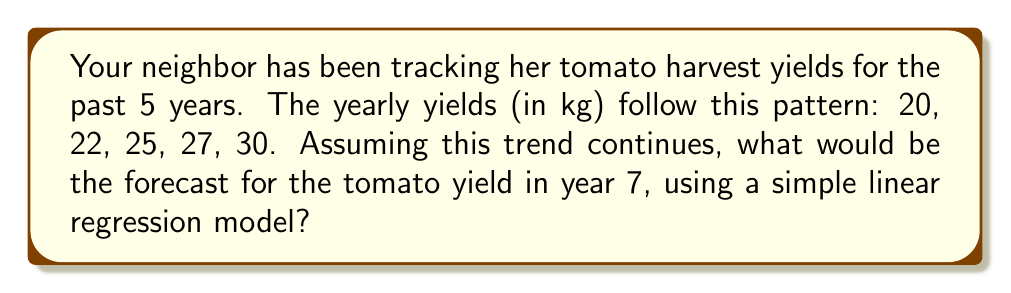Teach me how to tackle this problem. To forecast the tomato yield for year 7 using a simple linear regression model, we'll follow these steps:

1) First, let's set up our data:
   x (year): 1, 2, 3, 4, 5
   y (yield): 20, 22, 25, 27, 30

2) We need to calculate the slope (m) and y-intercept (b) for the line y = mx + b.

3) The slope formula is:
   $$m = \frac{n\sum xy - \sum x \sum y}{n\sum x^2 - (\sum x)^2}$$

   Where n is the number of data points (5 in this case).

4) Let's calculate the necessary sums:
   $\sum x = 1 + 2 + 3 + 4 + 5 = 15$
   $\sum y = 20 + 22 + 25 + 27 + 30 = 124$
   $\sum xy = 1(20) + 2(22) + 3(25) + 4(27) + 5(30) = 414$
   $\sum x^2 = 1^2 + 2^2 + 3^2 + 4^2 + 5^2 = 55$

5) Now we can calculate the slope:
   $$m = \frac{5(414) - 15(124)}{5(55) - 15^2} = \frac{2070 - 1860}{275 - 225} = \frac{210}{50} = 4.2$$

6) To find b, we can use the formula:
   $$b = \frac{\sum y - m\sum x}{n}$$

   $$b = \frac{124 - 4.2(15)}{5} = \frac{124 - 63}{5} = \frac{61}{5} = 12.2$$

7) So our line equation is: y = 4.2x + 12.2

8) To forecast for year 7, we substitute x = 7:
   y = 4.2(7) + 12.2 = 29.4 + 12.2 = 41.6

Therefore, the forecast for the tomato yield in year 7 is 41.6 kg.
Answer: 41.6 kg 